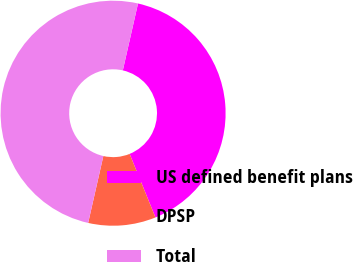Convert chart. <chart><loc_0><loc_0><loc_500><loc_500><pie_chart><fcel>US defined benefit plans<fcel>DPSP<fcel>Total<nl><fcel>40.3%<fcel>9.7%<fcel>50.0%<nl></chart> 